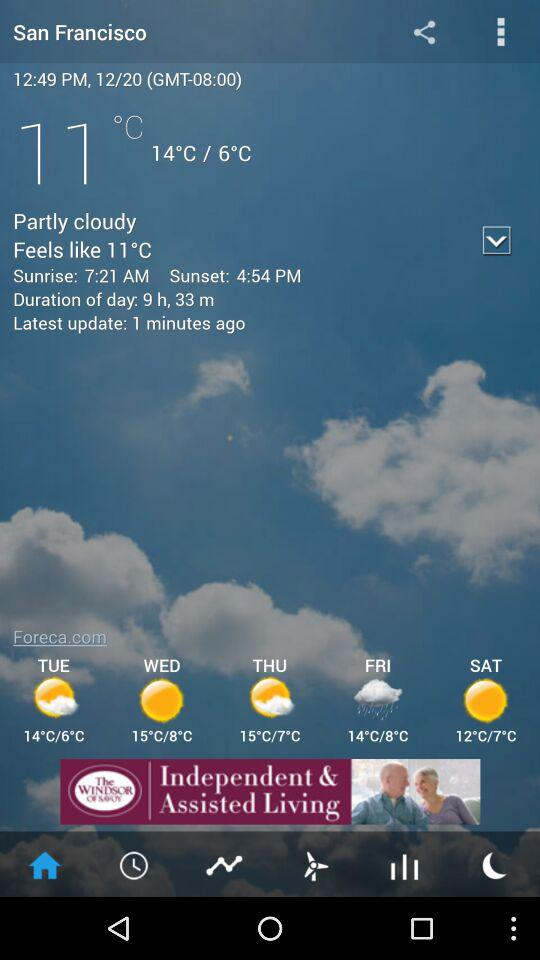What is the forecast for Thursday's weather? The weather is partly cloudy. 